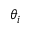<formula> <loc_0><loc_0><loc_500><loc_500>\theta _ { i }</formula> 